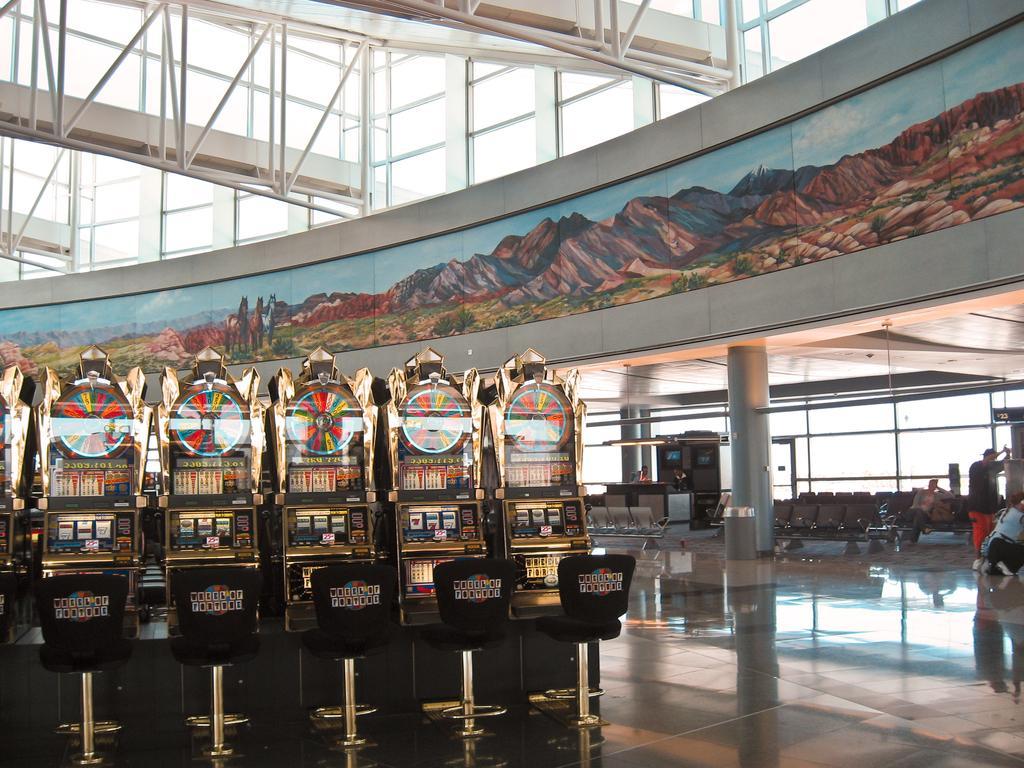Could you give a brief overview of what you see in this image? In this picture I can observe five machines. In front of them there are chairs. On the right side I can observe some people and a pillar. In front of the pillar there is a trash bin. In the background I can observe an art on the wall. 